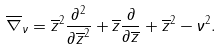<formula> <loc_0><loc_0><loc_500><loc_500>\overline { \nabla } _ { \nu } = \overline { z } ^ { 2 } \frac { \partial ^ { 2 } } { \partial \overline { z } ^ { 2 } } + \overline { z } \frac { \partial } { \partial \overline { z } } + \overline { z } ^ { 2 } - \nu ^ { 2 } .</formula> 